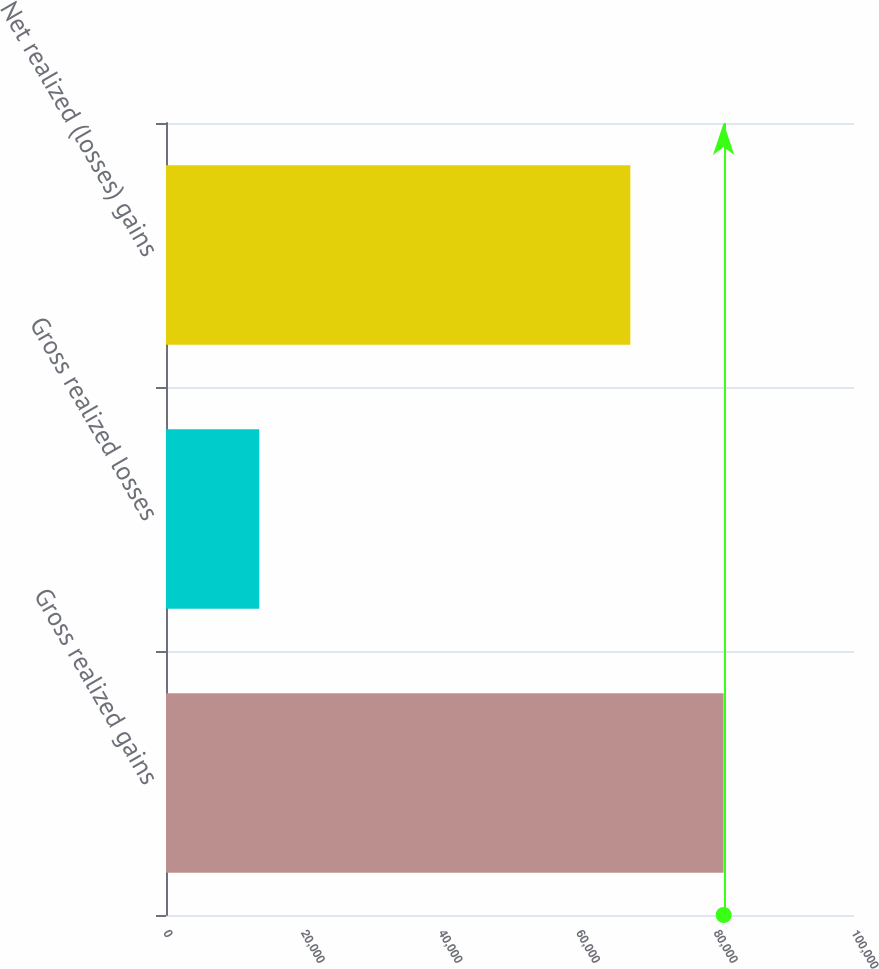Convert chart. <chart><loc_0><loc_0><loc_500><loc_500><bar_chart><fcel>Gross realized gains<fcel>Gross realized losses<fcel>Net realized (losses) gains<nl><fcel>81052<fcel>13556<fcel>67496<nl></chart> 